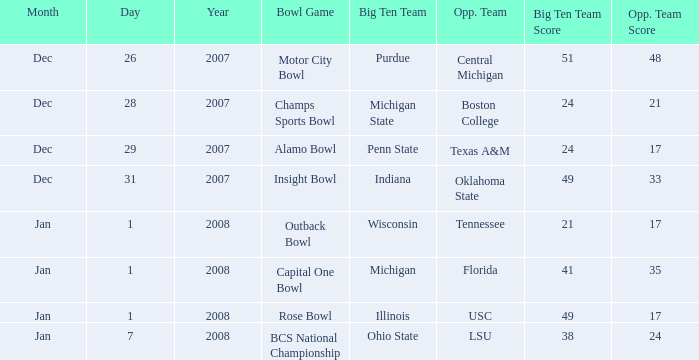Who was the opposing team in the game with a score of 21-17? Tennessee. 